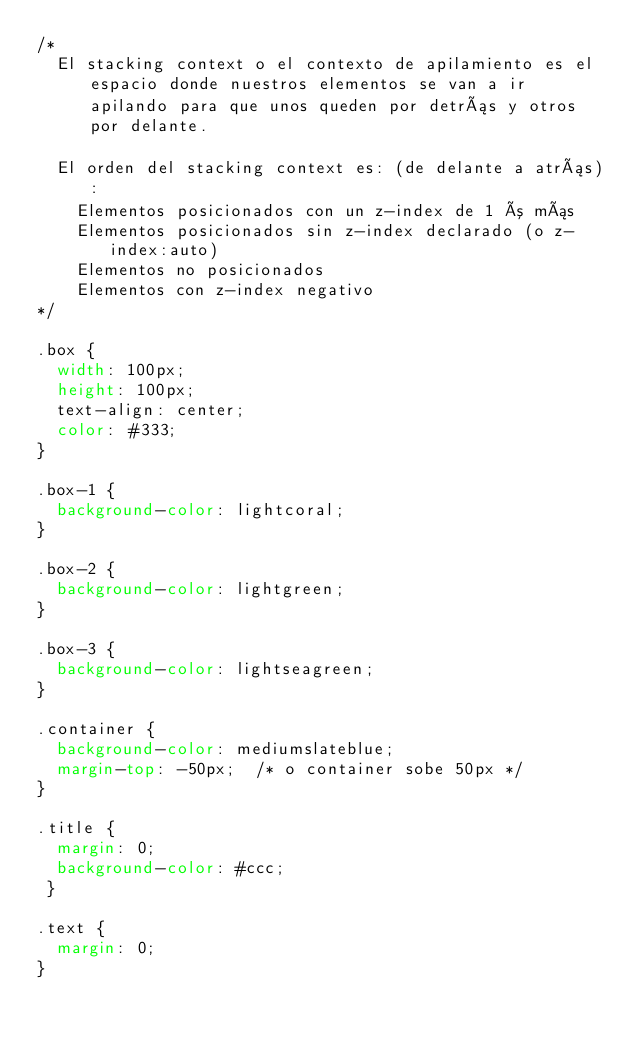Convert code to text. <code><loc_0><loc_0><loc_500><loc_500><_CSS_>/*
  El stacking context o el contexto de apilamiento es el espacio donde nuestros elementos se van a ir apilando para que unos queden por detrás y otros por delante.

  El orden del stacking context es: (de delante a atrás):
    Elementos posicionados con un z-index de 1 ó más
    Elementos posicionados sin z-index declarado (o z-index:auto)
    Elementos no posicionados
    Elementos con z-index negativo
*/

.box {
  width: 100px;
  height: 100px;
  text-align: center;
  color: #333;
}

.box-1 {
  background-color: lightcoral;
}

.box-2 {
  background-color: lightgreen;
}

.box-3 {
  background-color: lightseagreen;
}

.container {
  background-color: mediumslateblue;
  margin-top: -50px;  /* o container sobe 50px */
}

.title {
  margin: 0;
  background-color: #ccc;
 }

.text {
  margin: 0;
}
</code> 